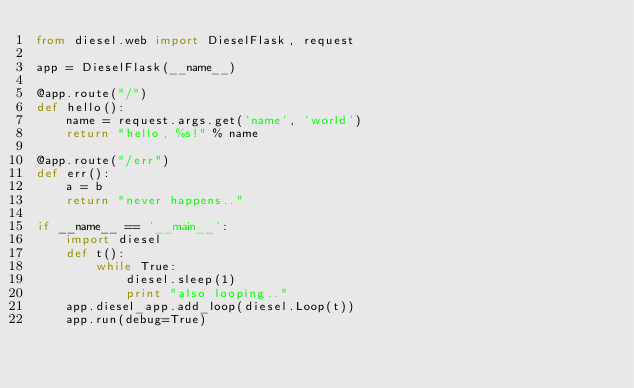Convert code to text. <code><loc_0><loc_0><loc_500><loc_500><_Python_>from diesel.web import DieselFlask, request

app = DieselFlask(__name__)

@app.route("/")
def hello():
    name = request.args.get('name', 'world')
    return "hello, %s!" % name

@app.route("/err")
def err():
    a = b
    return "never happens.."

if __name__ == '__main__':
    import diesel
    def t():
        while True:
            diesel.sleep(1)
            print "also looping.."
    app.diesel_app.add_loop(diesel.Loop(t))
    app.run(debug=True)
</code> 